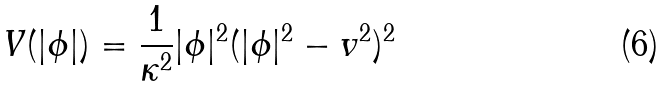<formula> <loc_0><loc_0><loc_500><loc_500>V ( | \phi | ) = \frac { 1 } { \kappa ^ { 2 } } | \phi | ^ { 2 } ( | \phi | ^ { 2 } - v ^ { 2 } ) ^ { 2 }</formula> 